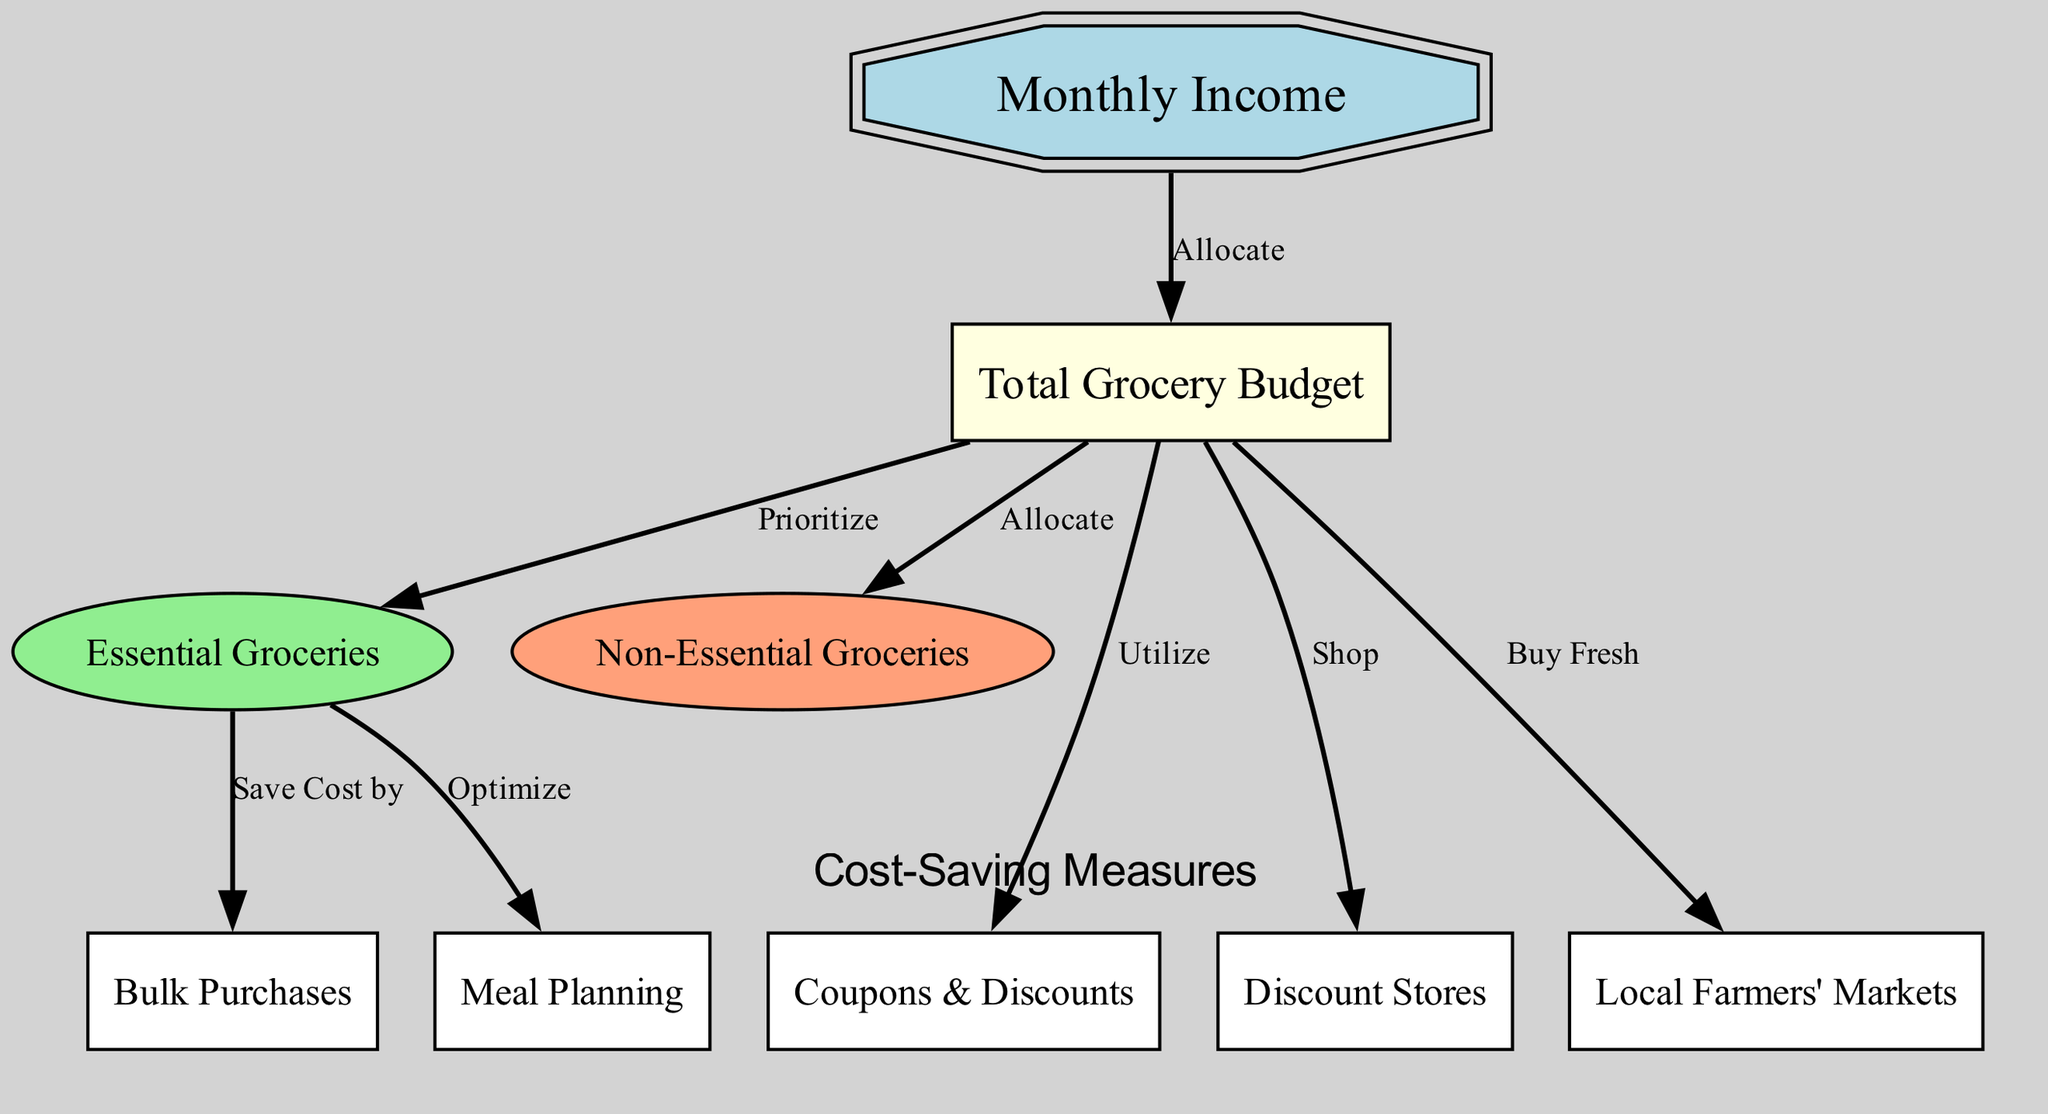What is the first node in the diagram? The first node listed under "nodes" in the diagram data is "Monthly Income."
Answer: Monthly Income How many nodes are there in total? The diagram contains eight nodes as counted from the data provided.
Answer: Eight What is the relationship between "Total Grocery Budget" and "Essential Groceries"? The label of the edge from "Total Grocery Budget" to "Essential Groceries" is "Prioritize."
Answer: Prioritize Which cost-saving measure is directly related to "Essential Groceries"? The edge from "Essential Groceries" to "Bulk Purchases" has the label "Save Cost by."
Answer: Save Cost by Name one place where you can buy fresh groceries according to the diagram. The diagram lists "Local Farmers' Markets" as a place to buy fresh groceries.
Answer: Local Farmers' Markets What is the connection between "Total Grocery Budget" and "Coupons & Discounts"? The relationship shown by the edge from "Total Grocery Budget" to "Coupons & Discounts" indicates to "Utilize."
Answer: Utilize What kind of grocery items should be prioritized based on the allocation? The edge demonstrates that "Essential Groceries" should be prioritized, as this is directly connected to the "Total Grocery Budget."
Answer: Essential Groceries How does "Meal Planning" optimize grocery spending? It optimizes spending by being directly connected to "Essential Groceries" with the label "Optimize."
Answer: Optimize Which type of groceries can be allocated after the essential ones? The edge from "Total Grocery Budget" to "Non-Essential Groceries" indicates that non-essential groceries can be allocated afterward.
Answer: Non-Essential Groceries 